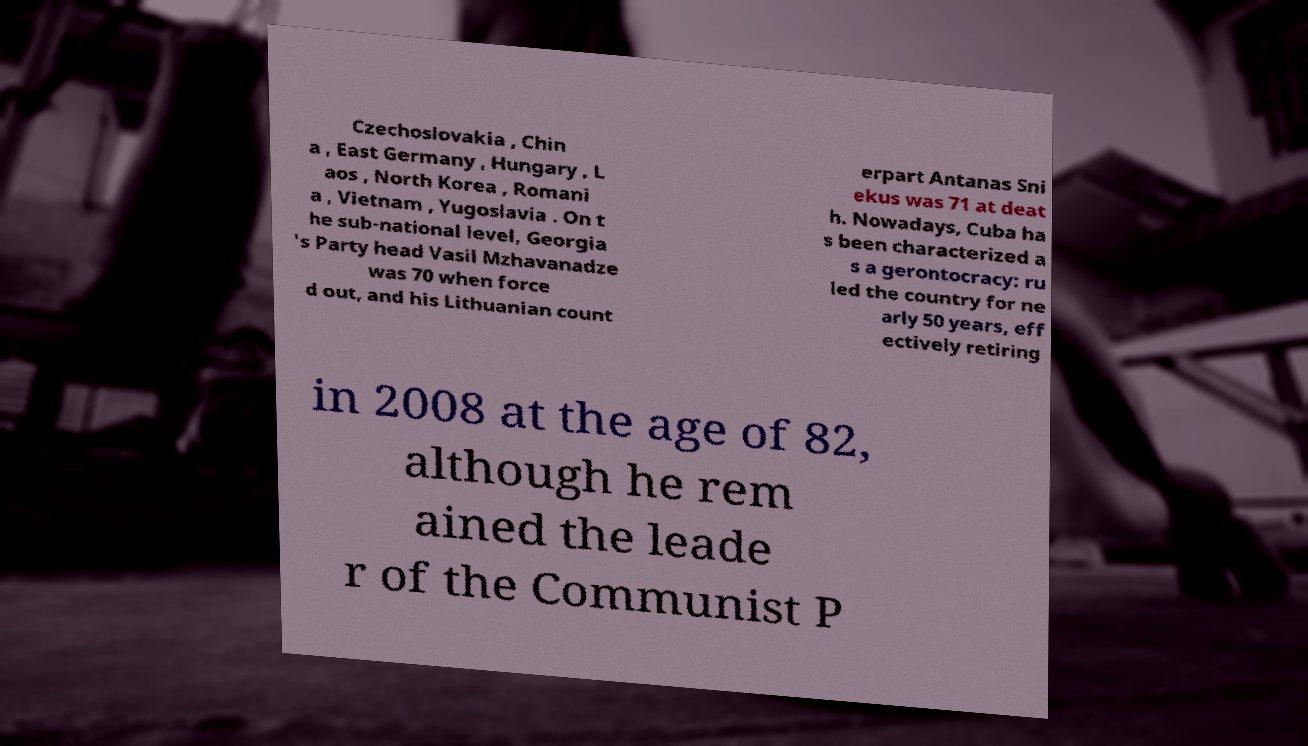Please identify and transcribe the text found in this image. Czechoslovakia , Chin a , East Germany , Hungary , L aos , North Korea , Romani a , Vietnam , Yugoslavia . On t he sub-national level, Georgia 's Party head Vasil Mzhavanadze was 70 when force d out, and his Lithuanian count erpart Antanas Sni ekus was 71 at deat h. Nowadays, Cuba ha s been characterized a s a gerontocracy: ru led the country for ne arly 50 years, eff ectively retiring in 2008 at the age of 82, although he rem ained the leade r of the Communist P 